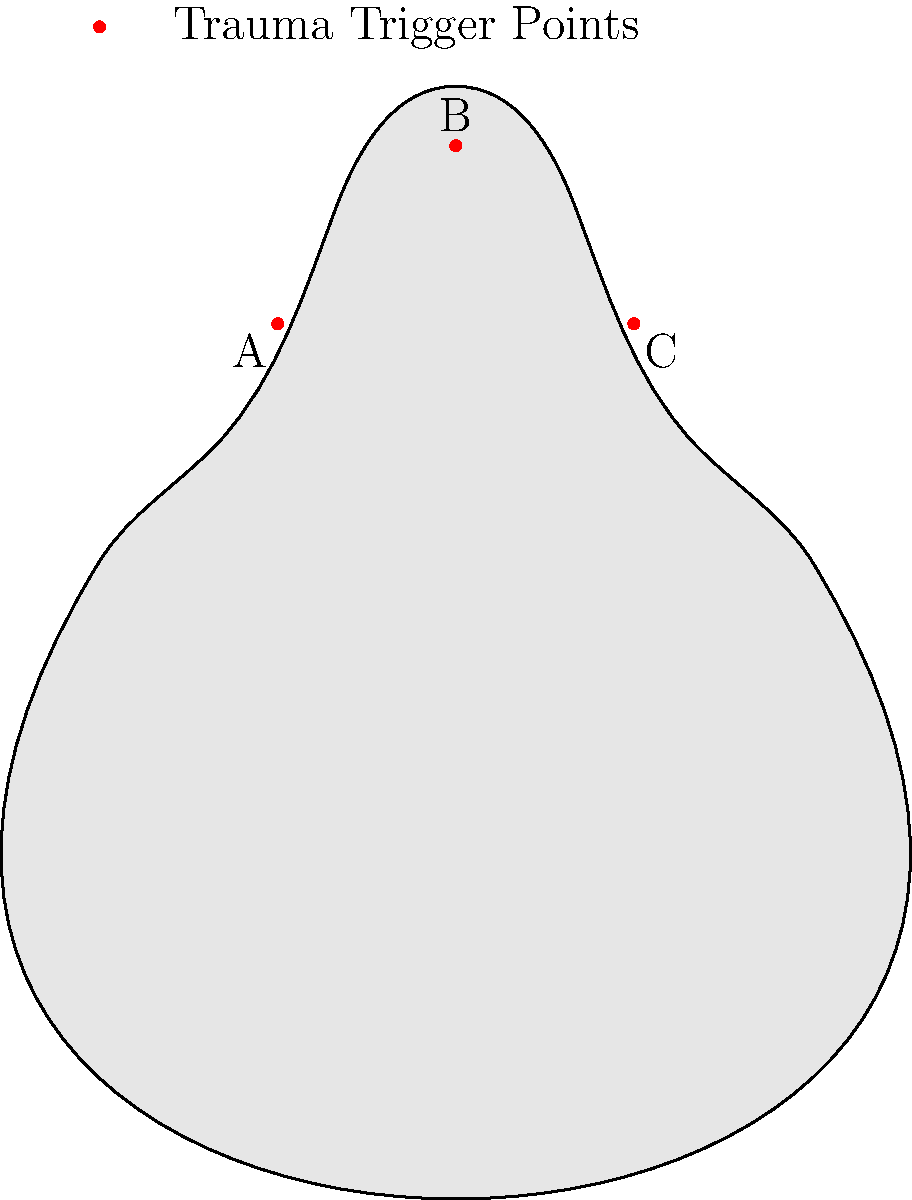On the body outline provided, three potential trauma trigger points are marked as A, B, and C. Based on your understanding of complex trauma and its physical manifestations, which point is most likely associated with hypervigilance and tension in the upper body? To answer this question, we need to consider the following steps:

1. Understand the concept of hypervigilance in complex trauma:
   Hypervigilance is a state of increased alertness and sensitivity to potential threats, common in trauma survivors.

2. Recognize physical manifestations of hypervigilance:
   It often manifests as tension in the upper body, particularly in the neck, shoulders, and upper back.

3. Analyze the marked points on the body outline:
   A: Located in the lower torso
   B: Positioned in the upper chest/neck area
   C: Situated in the lower back region

4. Connect hypervigilance symptoms to body locations:
   The upper chest/neck area (point B) is most closely associated with tension and hypervigilance in trauma survivors.

5. Consider the impact on the nervous system:
   The upper body, especially the neck and chest, houses important components of the autonomic nervous system, which is often dysregulated in complex trauma.

Given this analysis, point B is the most likely location associated with hypervigilance and tension in the upper body for a survivor of complex trauma.
Answer: B 